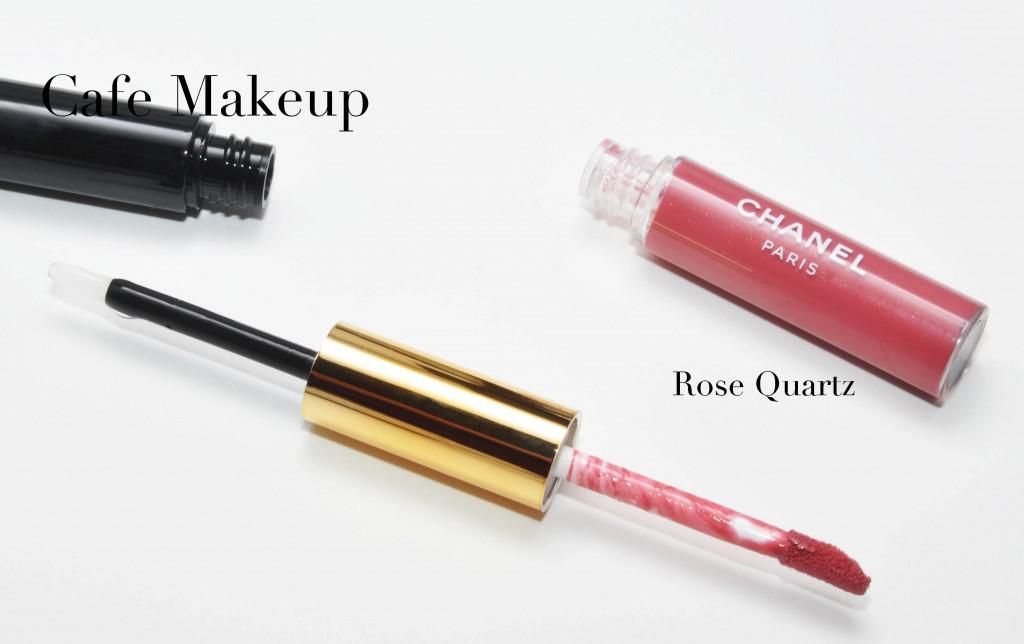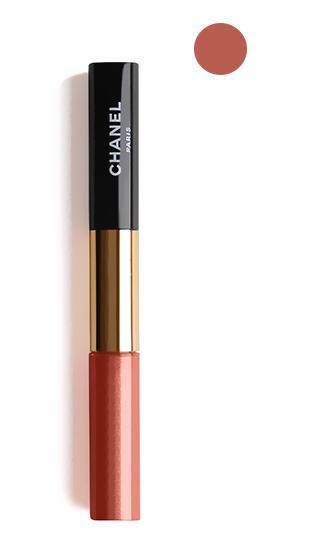The first image is the image on the left, the second image is the image on the right. Examine the images to the left and right. Is the description "The left image contains an uncapped lipstick wand, and the right image includes at least one capped lip makeup." accurate? Answer yes or no. Yes. 